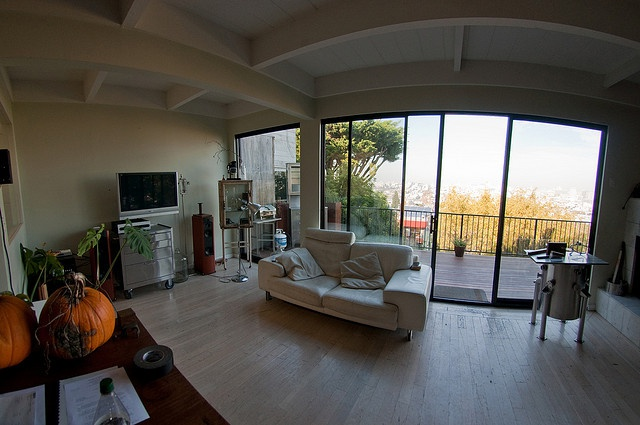Describe the objects in this image and their specific colors. I can see couch in black and gray tones, tv in black, gray, and darkgray tones, potted plant in black, darkgreen, and gray tones, bottle in black and gray tones, and dining table in black, lightgray, gray, and blue tones in this image. 